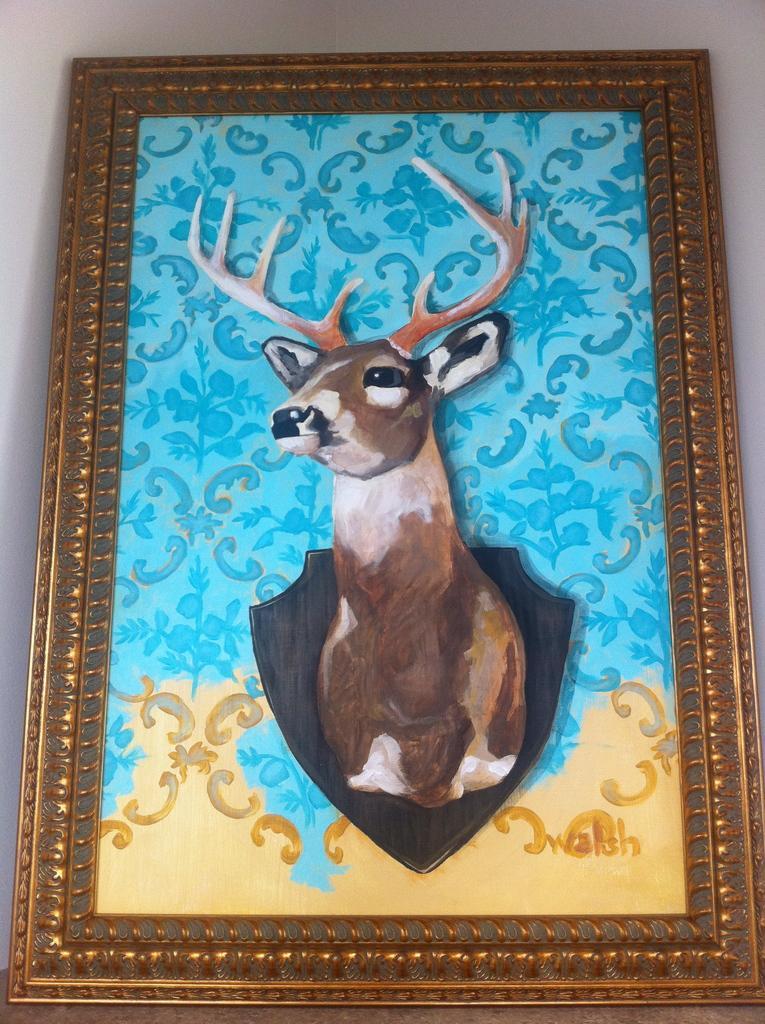Can you describe this image briefly? In this image there is a frame of a painting. In the painting there is a deer. In the background there is wall. 